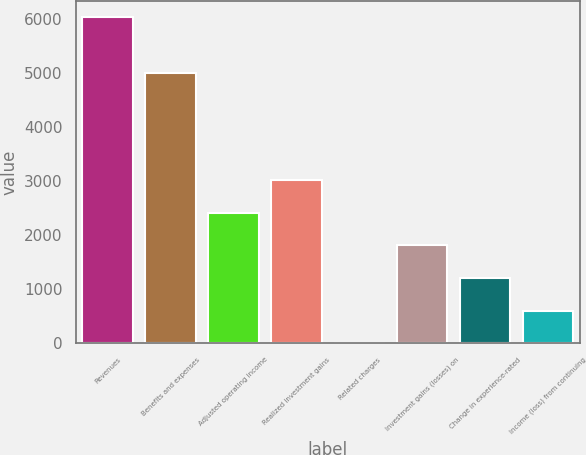<chart> <loc_0><loc_0><loc_500><loc_500><bar_chart><fcel>Revenues<fcel>Benefits and expenses<fcel>Adjusted operating income<fcel>Realized investment gains<fcel>Related charges<fcel>Investment gains (losses) on<fcel>Change in experience-rated<fcel>Income (loss) from continuing<nl><fcel>6028<fcel>4989<fcel>2411.8<fcel>3014.5<fcel>1<fcel>1809.1<fcel>1206.4<fcel>603.7<nl></chart> 